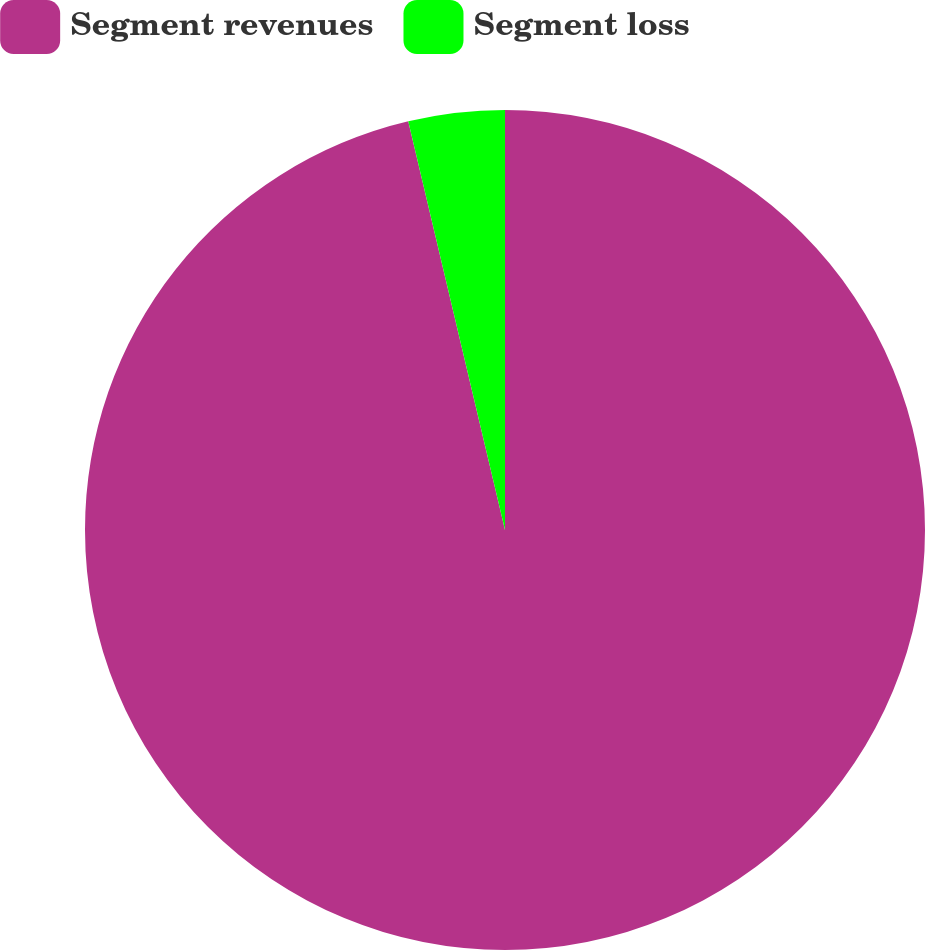Convert chart to OTSL. <chart><loc_0><loc_0><loc_500><loc_500><pie_chart><fcel>Segment revenues<fcel>Segment loss<nl><fcel>96.3%<fcel>3.7%<nl></chart> 